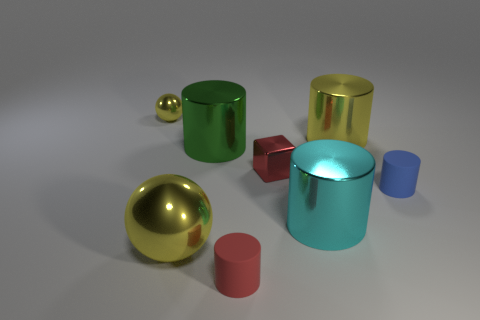Is there any other thing that is the same shape as the red metallic object?
Offer a very short reply. No. What is the color of the other object that is the same shape as the small yellow shiny object?
Ensure brevity in your answer.  Yellow. How many tiny things have the same color as the large metal sphere?
Provide a short and direct response. 1. The small matte thing that is on the right side of the red matte object that is right of the large metallic object on the left side of the big green shiny thing is what color?
Offer a very short reply. Blue. Does the tiny yellow sphere have the same material as the small blue cylinder?
Provide a short and direct response. No. Is the shape of the big cyan metal thing the same as the large green thing?
Your response must be concise. Yes. Is the number of large cyan cylinders to the left of the big cyan thing the same as the number of large yellow metallic balls that are to the right of the large green metallic cylinder?
Provide a short and direct response. Yes. What is the color of the other cylinder that is made of the same material as the tiny blue cylinder?
Give a very brief answer. Red. How many cyan cylinders have the same material as the small yellow thing?
Your answer should be very brief. 1. Does the big metal cylinder that is behind the green object have the same color as the large metal sphere?
Offer a terse response. Yes. 